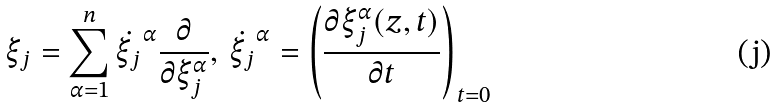Convert formula to latex. <formula><loc_0><loc_0><loc_500><loc_500>\xi _ { j } = \sum _ { \alpha = 1 } ^ { n } \dot { \xi _ { j } } ^ { \alpha } \frac { \partial } { \partial \xi _ { j } ^ { \alpha } } , \, \dot { \xi _ { j } } ^ { \alpha } = \left ( \frac { \partial \xi _ { j } ^ { \alpha } ( z , t ) } { \partial t } \right ) _ { t = 0 }</formula> 